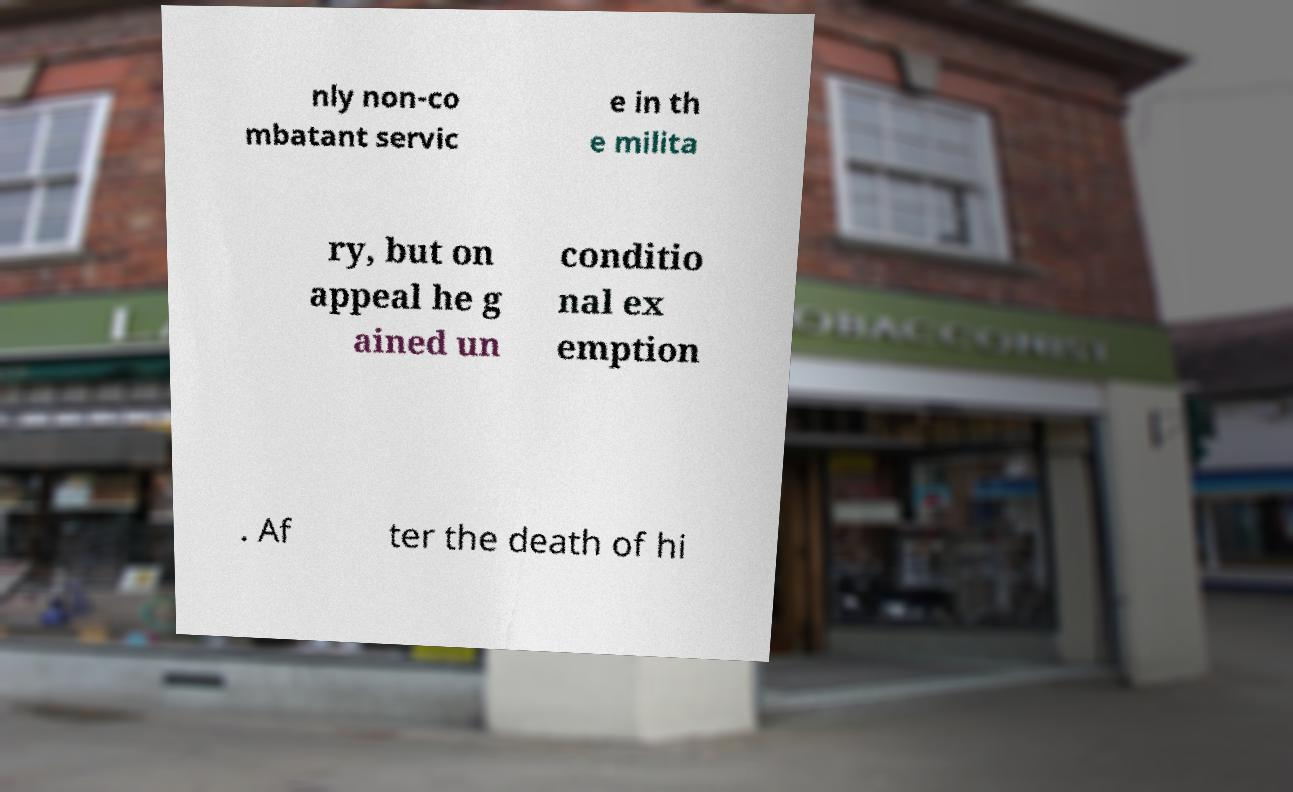Can you accurately transcribe the text from the provided image for me? nly non-co mbatant servic e in th e milita ry, but on appeal he g ained un conditio nal ex emption . Af ter the death of hi 